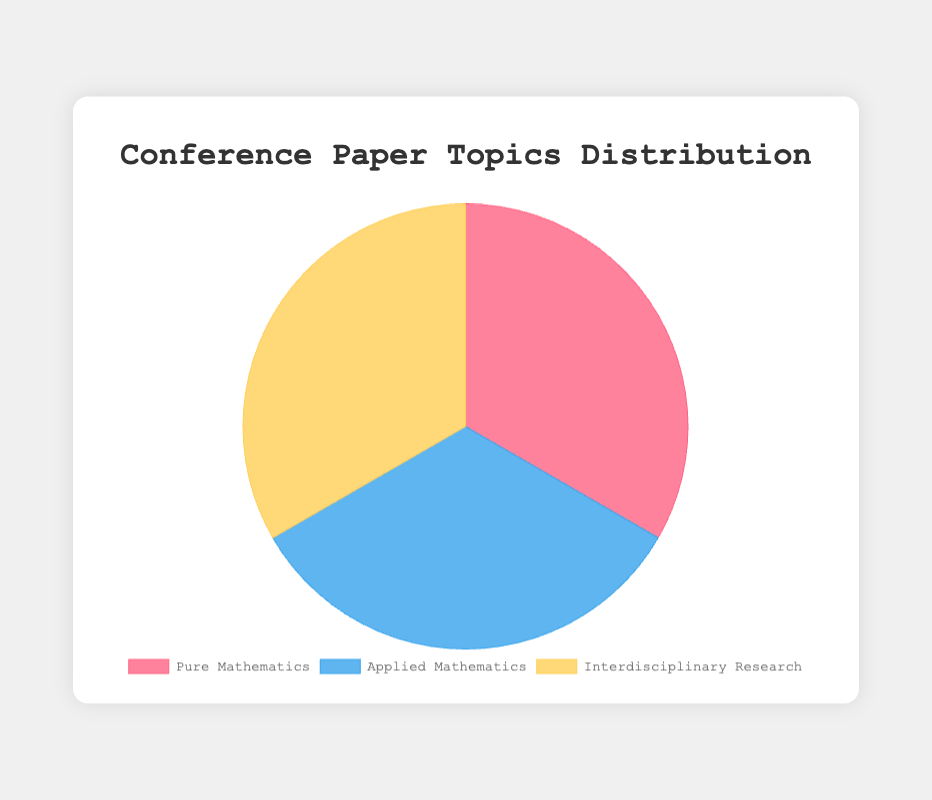What is the total number of papers for Pure Mathematics? Pure Mathematics includes 40 papers in Algebraic Topology, 25 in Number Theory, and 35 in Complex Analysis. So, the total number of papers is 40 + 25 + 35 = 100
Answer: 100 Which category has the largest share in the pie chart? The pie chart shows three categories: Pure Mathematics, Applied Mathematics, and Interdisciplinary Research, each contributing 100 papers. Since all values are equal, no single category has a larger share.
Answer: No category How does the sum of Applied Mathematics papers compare to Interdisciplinary Research papers? Both categories consist of 100 papers each. Since 100 = 100, they are equal.
Answer: Equal What is the proportion of Computational Fluid Dynamics papers within the Applied Mathematics category? The total number of papers in Applied Mathematics is 45 + 30 + 25 = 100. The proportion of Computational Fluid Dynamics is (45 / 100) * 100% = 45%.
Answer: 45% What category does the yellow region in the pie chart represent? The yellow region corresponds to Interdisciplinary Research as indicated by the legend.
Answer: Interdisciplinary Research If you sum the number of papers in Number Theory and Mathematical Biology, what proportion do they represent out of the entire dataset? Number Theory has 25 papers and Mathematical Biology has 30. The total papers in the dataset are 100 (Pure Math) + 100 (Applied Math) + 100 (Interdisciplinary) = 300. So, the proportion is (25 + 30) / 300 * 100% = 18.33%.
Answer: 18.33% Which color represents the Pure Mathematics category? The red region is designated for Pure Mathematics based on the legend.
Answer: Red How does the number of Bioinformatics papers compare to the number of Operations Research papers? Bioinformatics has 20 papers, while Operations Research has 25. Therefore, Operations Research has more papers.
Answer: Operations Research has more What is the average number of papers per topic within Interdisciplinary Research? Interdisciplinary Research includes 50 papers in Mathematical Physics, 30 in Data Science, and 20 in Bioinformatics. So, the average is (50 + 30 + 20) / 3 = 33.33.
Answer: 33.33 What category is represented by the blue region in the pie chart? According to the legend, the blue region represents Applied Mathematics.
Answer: Applied Mathematics 